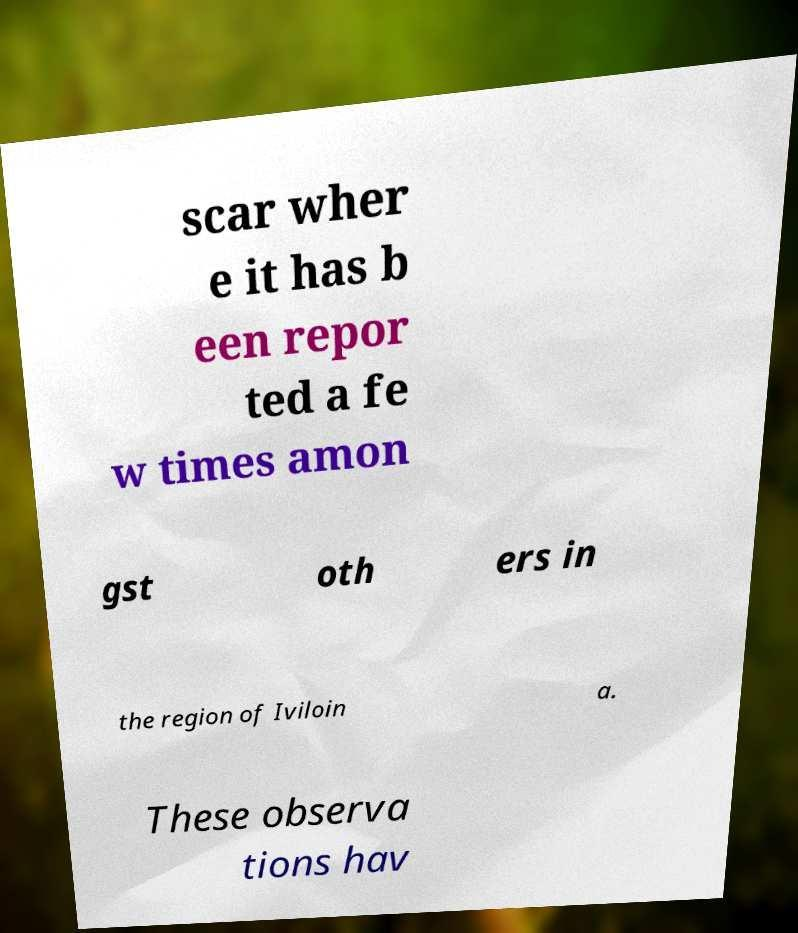For documentation purposes, I need the text within this image transcribed. Could you provide that? scar wher e it has b een repor ted a fe w times amon gst oth ers in the region of Iviloin a. These observa tions hav 